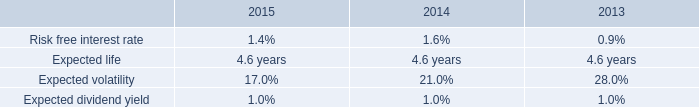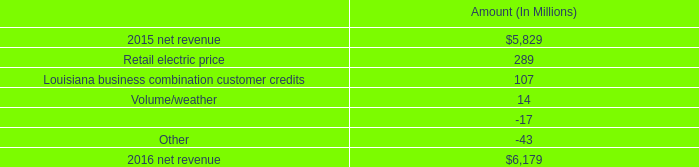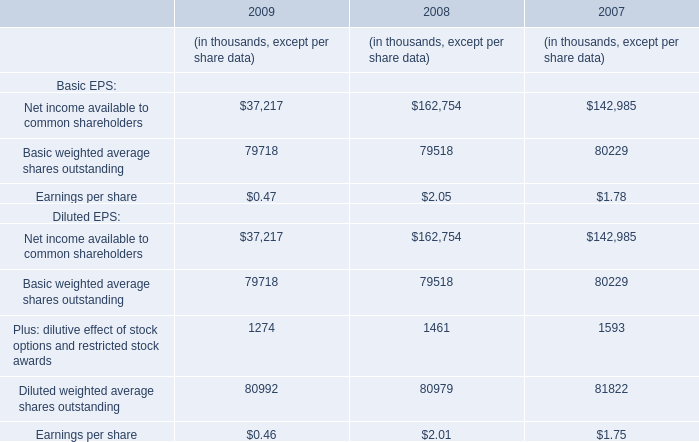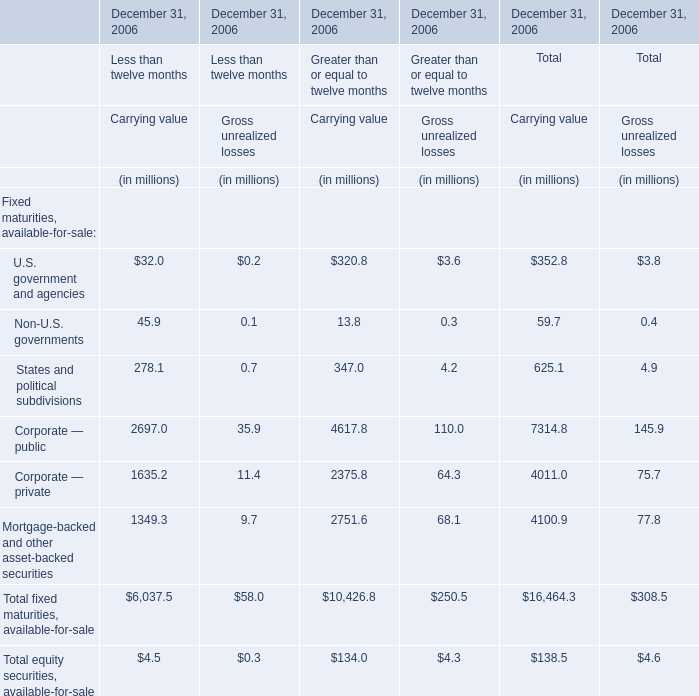what is the growth rate in net revenue in 2016? 
Computations: ((6179 - 5829) / 5829)
Answer: 0.06004. 